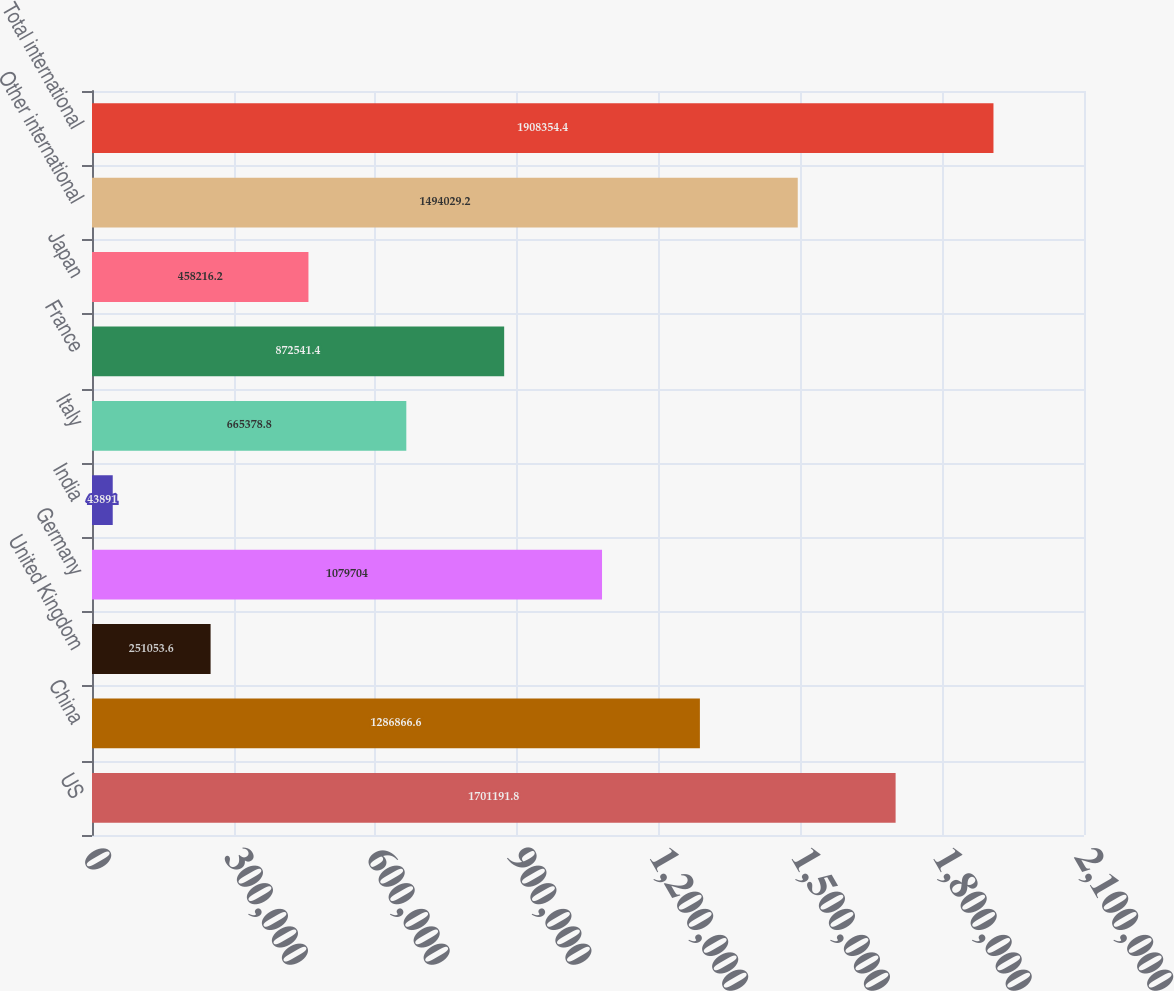Convert chart. <chart><loc_0><loc_0><loc_500><loc_500><bar_chart><fcel>US<fcel>China<fcel>United Kingdom<fcel>Germany<fcel>India<fcel>Italy<fcel>France<fcel>Japan<fcel>Other international<fcel>Total international<nl><fcel>1.70119e+06<fcel>1.28687e+06<fcel>251054<fcel>1.0797e+06<fcel>43891<fcel>665379<fcel>872541<fcel>458216<fcel>1.49403e+06<fcel>1.90835e+06<nl></chart> 